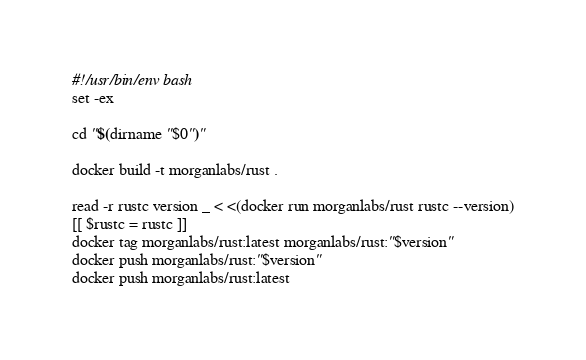Convert code to text. <code><loc_0><loc_0><loc_500><loc_500><_Bash_>#!/usr/bin/env bash
set -ex

cd "$(dirname "$0")"

docker build -t morganlabs/rust .

read -r rustc version _ < <(docker run morganlabs/rust rustc --version)
[[ $rustc = rustc ]]
docker tag morganlabs/rust:latest morganlabs/rust:"$version"
docker push morganlabs/rust:"$version"
docker push morganlabs/rust:latest
</code> 